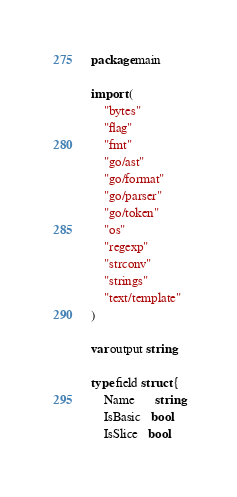Convert code to text. <code><loc_0><loc_0><loc_500><loc_500><_Go_>package main

import (
	"bytes"
	"flag"
	"fmt"
	"go/ast"
	"go/format"
	"go/parser"
	"go/token"
	"os"
	"regexp"
	"strconv"
	"strings"
	"text/template"
)

var output string

type field struct {
	Name      string
	IsBasic   bool
	IsSlice   bool</code> 